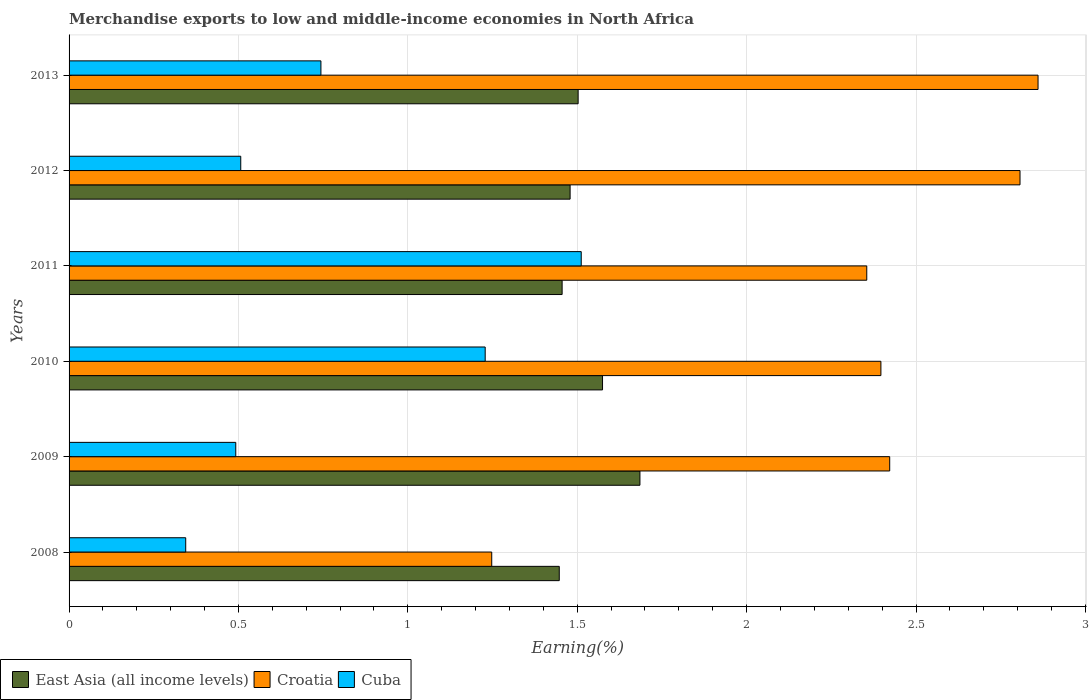How many groups of bars are there?
Provide a short and direct response. 6. How many bars are there on the 3rd tick from the top?
Keep it short and to the point. 3. How many bars are there on the 5th tick from the bottom?
Ensure brevity in your answer.  3. In how many cases, is the number of bars for a given year not equal to the number of legend labels?
Provide a succinct answer. 0. What is the percentage of amount earned from merchandise exports in Cuba in 2009?
Provide a succinct answer. 0.49. Across all years, what is the maximum percentage of amount earned from merchandise exports in Cuba?
Offer a terse response. 1.51. Across all years, what is the minimum percentage of amount earned from merchandise exports in Cuba?
Your answer should be very brief. 0.34. What is the total percentage of amount earned from merchandise exports in Cuba in the graph?
Make the answer very short. 4.83. What is the difference between the percentage of amount earned from merchandise exports in Croatia in 2008 and that in 2009?
Make the answer very short. -1.17. What is the difference between the percentage of amount earned from merchandise exports in Cuba in 2013 and the percentage of amount earned from merchandise exports in East Asia (all income levels) in 2012?
Offer a very short reply. -0.74. What is the average percentage of amount earned from merchandise exports in East Asia (all income levels) per year?
Provide a short and direct response. 1.52. In the year 2013, what is the difference between the percentage of amount earned from merchandise exports in East Asia (all income levels) and percentage of amount earned from merchandise exports in Croatia?
Offer a terse response. -1.36. In how many years, is the percentage of amount earned from merchandise exports in Cuba greater than 1.3 %?
Provide a short and direct response. 1. What is the ratio of the percentage of amount earned from merchandise exports in East Asia (all income levels) in 2010 to that in 2011?
Your answer should be compact. 1.08. What is the difference between the highest and the second highest percentage of amount earned from merchandise exports in Cuba?
Your answer should be very brief. 0.28. What is the difference between the highest and the lowest percentage of amount earned from merchandise exports in East Asia (all income levels)?
Make the answer very short. 0.24. Is the sum of the percentage of amount earned from merchandise exports in Croatia in 2009 and 2012 greater than the maximum percentage of amount earned from merchandise exports in Cuba across all years?
Offer a terse response. Yes. What does the 2nd bar from the top in 2013 represents?
Your answer should be very brief. Croatia. What does the 3rd bar from the bottom in 2011 represents?
Your answer should be very brief. Cuba. Is it the case that in every year, the sum of the percentage of amount earned from merchandise exports in Croatia and percentage of amount earned from merchandise exports in Cuba is greater than the percentage of amount earned from merchandise exports in East Asia (all income levels)?
Your answer should be very brief. Yes. How many bars are there?
Make the answer very short. 18. What is the difference between two consecutive major ticks on the X-axis?
Provide a short and direct response. 0.5. Are the values on the major ticks of X-axis written in scientific E-notation?
Your answer should be compact. No. Does the graph contain grids?
Provide a succinct answer. Yes. Where does the legend appear in the graph?
Make the answer very short. Bottom left. How many legend labels are there?
Make the answer very short. 3. What is the title of the graph?
Provide a short and direct response. Merchandise exports to low and middle-income economies in North Africa. What is the label or title of the X-axis?
Your answer should be compact. Earning(%). What is the Earning(%) of East Asia (all income levels) in 2008?
Provide a short and direct response. 1.45. What is the Earning(%) of Croatia in 2008?
Give a very brief answer. 1.25. What is the Earning(%) of Cuba in 2008?
Make the answer very short. 0.34. What is the Earning(%) of East Asia (all income levels) in 2009?
Your answer should be compact. 1.69. What is the Earning(%) of Croatia in 2009?
Give a very brief answer. 2.42. What is the Earning(%) in Cuba in 2009?
Your response must be concise. 0.49. What is the Earning(%) in East Asia (all income levels) in 2010?
Give a very brief answer. 1.57. What is the Earning(%) in Croatia in 2010?
Ensure brevity in your answer.  2.4. What is the Earning(%) of Cuba in 2010?
Keep it short and to the point. 1.23. What is the Earning(%) of East Asia (all income levels) in 2011?
Give a very brief answer. 1.46. What is the Earning(%) in Croatia in 2011?
Provide a short and direct response. 2.35. What is the Earning(%) in Cuba in 2011?
Give a very brief answer. 1.51. What is the Earning(%) of East Asia (all income levels) in 2012?
Your answer should be compact. 1.48. What is the Earning(%) of Croatia in 2012?
Ensure brevity in your answer.  2.81. What is the Earning(%) in Cuba in 2012?
Your answer should be compact. 0.51. What is the Earning(%) of East Asia (all income levels) in 2013?
Make the answer very short. 1.5. What is the Earning(%) in Croatia in 2013?
Your answer should be very brief. 2.86. What is the Earning(%) of Cuba in 2013?
Provide a short and direct response. 0.74. Across all years, what is the maximum Earning(%) of East Asia (all income levels)?
Make the answer very short. 1.69. Across all years, what is the maximum Earning(%) of Croatia?
Your answer should be very brief. 2.86. Across all years, what is the maximum Earning(%) of Cuba?
Offer a very short reply. 1.51. Across all years, what is the minimum Earning(%) in East Asia (all income levels)?
Ensure brevity in your answer.  1.45. Across all years, what is the minimum Earning(%) of Croatia?
Make the answer very short. 1.25. Across all years, what is the minimum Earning(%) of Cuba?
Offer a very short reply. 0.34. What is the total Earning(%) in East Asia (all income levels) in the graph?
Provide a succinct answer. 9.14. What is the total Earning(%) in Croatia in the graph?
Offer a very short reply. 14.09. What is the total Earning(%) in Cuba in the graph?
Ensure brevity in your answer.  4.83. What is the difference between the Earning(%) in East Asia (all income levels) in 2008 and that in 2009?
Make the answer very short. -0.24. What is the difference between the Earning(%) of Croatia in 2008 and that in 2009?
Make the answer very short. -1.17. What is the difference between the Earning(%) in Cuba in 2008 and that in 2009?
Offer a very short reply. -0.15. What is the difference between the Earning(%) in East Asia (all income levels) in 2008 and that in 2010?
Offer a terse response. -0.13. What is the difference between the Earning(%) of Croatia in 2008 and that in 2010?
Keep it short and to the point. -1.15. What is the difference between the Earning(%) in Cuba in 2008 and that in 2010?
Give a very brief answer. -0.88. What is the difference between the Earning(%) in East Asia (all income levels) in 2008 and that in 2011?
Give a very brief answer. -0.01. What is the difference between the Earning(%) in Croatia in 2008 and that in 2011?
Ensure brevity in your answer.  -1.11. What is the difference between the Earning(%) of Cuba in 2008 and that in 2011?
Give a very brief answer. -1.17. What is the difference between the Earning(%) of East Asia (all income levels) in 2008 and that in 2012?
Your response must be concise. -0.03. What is the difference between the Earning(%) in Croatia in 2008 and that in 2012?
Your answer should be very brief. -1.56. What is the difference between the Earning(%) of Cuba in 2008 and that in 2012?
Your answer should be very brief. -0.16. What is the difference between the Earning(%) in East Asia (all income levels) in 2008 and that in 2013?
Your response must be concise. -0.06. What is the difference between the Earning(%) of Croatia in 2008 and that in 2013?
Provide a short and direct response. -1.61. What is the difference between the Earning(%) of Cuba in 2008 and that in 2013?
Your response must be concise. -0.4. What is the difference between the Earning(%) of East Asia (all income levels) in 2009 and that in 2010?
Offer a very short reply. 0.11. What is the difference between the Earning(%) of Croatia in 2009 and that in 2010?
Your response must be concise. 0.03. What is the difference between the Earning(%) in Cuba in 2009 and that in 2010?
Provide a succinct answer. -0.74. What is the difference between the Earning(%) in East Asia (all income levels) in 2009 and that in 2011?
Make the answer very short. 0.23. What is the difference between the Earning(%) of Croatia in 2009 and that in 2011?
Ensure brevity in your answer.  0.07. What is the difference between the Earning(%) in Cuba in 2009 and that in 2011?
Offer a very short reply. -1.02. What is the difference between the Earning(%) of East Asia (all income levels) in 2009 and that in 2012?
Your answer should be compact. 0.21. What is the difference between the Earning(%) of Croatia in 2009 and that in 2012?
Your answer should be very brief. -0.38. What is the difference between the Earning(%) of Cuba in 2009 and that in 2012?
Offer a terse response. -0.01. What is the difference between the Earning(%) in East Asia (all income levels) in 2009 and that in 2013?
Provide a succinct answer. 0.18. What is the difference between the Earning(%) in Croatia in 2009 and that in 2013?
Offer a very short reply. -0.44. What is the difference between the Earning(%) in Cuba in 2009 and that in 2013?
Make the answer very short. -0.25. What is the difference between the Earning(%) in East Asia (all income levels) in 2010 and that in 2011?
Keep it short and to the point. 0.12. What is the difference between the Earning(%) of Croatia in 2010 and that in 2011?
Ensure brevity in your answer.  0.04. What is the difference between the Earning(%) in Cuba in 2010 and that in 2011?
Your answer should be very brief. -0.28. What is the difference between the Earning(%) of East Asia (all income levels) in 2010 and that in 2012?
Make the answer very short. 0.1. What is the difference between the Earning(%) of Croatia in 2010 and that in 2012?
Provide a succinct answer. -0.41. What is the difference between the Earning(%) in Cuba in 2010 and that in 2012?
Your answer should be compact. 0.72. What is the difference between the Earning(%) of East Asia (all income levels) in 2010 and that in 2013?
Offer a terse response. 0.07. What is the difference between the Earning(%) of Croatia in 2010 and that in 2013?
Your answer should be very brief. -0.46. What is the difference between the Earning(%) in Cuba in 2010 and that in 2013?
Your response must be concise. 0.48. What is the difference between the Earning(%) in East Asia (all income levels) in 2011 and that in 2012?
Ensure brevity in your answer.  -0.02. What is the difference between the Earning(%) of Croatia in 2011 and that in 2012?
Provide a short and direct response. -0.45. What is the difference between the Earning(%) of Cuba in 2011 and that in 2012?
Provide a succinct answer. 1.01. What is the difference between the Earning(%) of East Asia (all income levels) in 2011 and that in 2013?
Offer a very short reply. -0.05. What is the difference between the Earning(%) of Croatia in 2011 and that in 2013?
Your answer should be compact. -0.51. What is the difference between the Earning(%) in Cuba in 2011 and that in 2013?
Provide a short and direct response. 0.77. What is the difference between the Earning(%) of East Asia (all income levels) in 2012 and that in 2013?
Ensure brevity in your answer.  -0.02. What is the difference between the Earning(%) of Croatia in 2012 and that in 2013?
Provide a short and direct response. -0.05. What is the difference between the Earning(%) in Cuba in 2012 and that in 2013?
Provide a short and direct response. -0.24. What is the difference between the Earning(%) in East Asia (all income levels) in 2008 and the Earning(%) in Croatia in 2009?
Keep it short and to the point. -0.98. What is the difference between the Earning(%) of East Asia (all income levels) in 2008 and the Earning(%) of Cuba in 2009?
Your answer should be compact. 0.95. What is the difference between the Earning(%) in Croatia in 2008 and the Earning(%) in Cuba in 2009?
Make the answer very short. 0.76. What is the difference between the Earning(%) of East Asia (all income levels) in 2008 and the Earning(%) of Croatia in 2010?
Your response must be concise. -0.95. What is the difference between the Earning(%) in East Asia (all income levels) in 2008 and the Earning(%) in Cuba in 2010?
Your answer should be very brief. 0.22. What is the difference between the Earning(%) of Croatia in 2008 and the Earning(%) of Cuba in 2010?
Ensure brevity in your answer.  0.02. What is the difference between the Earning(%) of East Asia (all income levels) in 2008 and the Earning(%) of Croatia in 2011?
Your answer should be compact. -0.91. What is the difference between the Earning(%) in East Asia (all income levels) in 2008 and the Earning(%) in Cuba in 2011?
Give a very brief answer. -0.06. What is the difference between the Earning(%) of Croatia in 2008 and the Earning(%) of Cuba in 2011?
Keep it short and to the point. -0.26. What is the difference between the Earning(%) in East Asia (all income levels) in 2008 and the Earning(%) in Croatia in 2012?
Your response must be concise. -1.36. What is the difference between the Earning(%) in East Asia (all income levels) in 2008 and the Earning(%) in Cuba in 2012?
Make the answer very short. 0.94. What is the difference between the Earning(%) of Croatia in 2008 and the Earning(%) of Cuba in 2012?
Ensure brevity in your answer.  0.74. What is the difference between the Earning(%) of East Asia (all income levels) in 2008 and the Earning(%) of Croatia in 2013?
Provide a succinct answer. -1.41. What is the difference between the Earning(%) of East Asia (all income levels) in 2008 and the Earning(%) of Cuba in 2013?
Provide a short and direct response. 0.7. What is the difference between the Earning(%) in Croatia in 2008 and the Earning(%) in Cuba in 2013?
Give a very brief answer. 0.5. What is the difference between the Earning(%) in East Asia (all income levels) in 2009 and the Earning(%) in Croatia in 2010?
Keep it short and to the point. -0.71. What is the difference between the Earning(%) in East Asia (all income levels) in 2009 and the Earning(%) in Cuba in 2010?
Offer a terse response. 0.46. What is the difference between the Earning(%) of Croatia in 2009 and the Earning(%) of Cuba in 2010?
Offer a terse response. 1.19. What is the difference between the Earning(%) in East Asia (all income levels) in 2009 and the Earning(%) in Croatia in 2011?
Your answer should be very brief. -0.67. What is the difference between the Earning(%) in East Asia (all income levels) in 2009 and the Earning(%) in Cuba in 2011?
Offer a terse response. 0.17. What is the difference between the Earning(%) in Croatia in 2009 and the Earning(%) in Cuba in 2011?
Your response must be concise. 0.91. What is the difference between the Earning(%) of East Asia (all income levels) in 2009 and the Earning(%) of Croatia in 2012?
Make the answer very short. -1.12. What is the difference between the Earning(%) of East Asia (all income levels) in 2009 and the Earning(%) of Cuba in 2012?
Give a very brief answer. 1.18. What is the difference between the Earning(%) of Croatia in 2009 and the Earning(%) of Cuba in 2012?
Make the answer very short. 1.92. What is the difference between the Earning(%) of East Asia (all income levels) in 2009 and the Earning(%) of Croatia in 2013?
Give a very brief answer. -1.18. What is the difference between the Earning(%) of East Asia (all income levels) in 2009 and the Earning(%) of Cuba in 2013?
Offer a terse response. 0.94. What is the difference between the Earning(%) in Croatia in 2009 and the Earning(%) in Cuba in 2013?
Give a very brief answer. 1.68. What is the difference between the Earning(%) of East Asia (all income levels) in 2010 and the Earning(%) of Croatia in 2011?
Offer a terse response. -0.78. What is the difference between the Earning(%) of East Asia (all income levels) in 2010 and the Earning(%) of Cuba in 2011?
Give a very brief answer. 0.06. What is the difference between the Earning(%) of Croatia in 2010 and the Earning(%) of Cuba in 2011?
Give a very brief answer. 0.88. What is the difference between the Earning(%) in East Asia (all income levels) in 2010 and the Earning(%) in Croatia in 2012?
Your response must be concise. -1.23. What is the difference between the Earning(%) in East Asia (all income levels) in 2010 and the Earning(%) in Cuba in 2012?
Provide a succinct answer. 1.07. What is the difference between the Earning(%) in Croatia in 2010 and the Earning(%) in Cuba in 2012?
Give a very brief answer. 1.89. What is the difference between the Earning(%) in East Asia (all income levels) in 2010 and the Earning(%) in Croatia in 2013?
Make the answer very short. -1.29. What is the difference between the Earning(%) in East Asia (all income levels) in 2010 and the Earning(%) in Cuba in 2013?
Make the answer very short. 0.83. What is the difference between the Earning(%) in Croatia in 2010 and the Earning(%) in Cuba in 2013?
Ensure brevity in your answer.  1.65. What is the difference between the Earning(%) of East Asia (all income levels) in 2011 and the Earning(%) of Croatia in 2012?
Keep it short and to the point. -1.35. What is the difference between the Earning(%) in East Asia (all income levels) in 2011 and the Earning(%) in Cuba in 2012?
Offer a very short reply. 0.95. What is the difference between the Earning(%) of Croatia in 2011 and the Earning(%) of Cuba in 2012?
Your response must be concise. 1.85. What is the difference between the Earning(%) of East Asia (all income levels) in 2011 and the Earning(%) of Croatia in 2013?
Keep it short and to the point. -1.4. What is the difference between the Earning(%) of East Asia (all income levels) in 2011 and the Earning(%) of Cuba in 2013?
Ensure brevity in your answer.  0.71. What is the difference between the Earning(%) of Croatia in 2011 and the Earning(%) of Cuba in 2013?
Make the answer very short. 1.61. What is the difference between the Earning(%) of East Asia (all income levels) in 2012 and the Earning(%) of Croatia in 2013?
Your answer should be compact. -1.38. What is the difference between the Earning(%) in East Asia (all income levels) in 2012 and the Earning(%) in Cuba in 2013?
Your response must be concise. 0.74. What is the difference between the Earning(%) in Croatia in 2012 and the Earning(%) in Cuba in 2013?
Keep it short and to the point. 2.06. What is the average Earning(%) in East Asia (all income levels) per year?
Offer a very short reply. 1.52. What is the average Earning(%) of Croatia per year?
Ensure brevity in your answer.  2.35. What is the average Earning(%) in Cuba per year?
Ensure brevity in your answer.  0.8. In the year 2008, what is the difference between the Earning(%) in East Asia (all income levels) and Earning(%) in Croatia?
Make the answer very short. 0.2. In the year 2008, what is the difference between the Earning(%) in East Asia (all income levels) and Earning(%) in Cuba?
Your answer should be compact. 1.1. In the year 2008, what is the difference between the Earning(%) of Croatia and Earning(%) of Cuba?
Your response must be concise. 0.9. In the year 2009, what is the difference between the Earning(%) in East Asia (all income levels) and Earning(%) in Croatia?
Your response must be concise. -0.74. In the year 2009, what is the difference between the Earning(%) in East Asia (all income levels) and Earning(%) in Cuba?
Ensure brevity in your answer.  1.19. In the year 2009, what is the difference between the Earning(%) of Croatia and Earning(%) of Cuba?
Keep it short and to the point. 1.93. In the year 2010, what is the difference between the Earning(%) of East Asia (all income levels) and Earning(%) of Croatia?
Provide a short and direct response. -0.82. In the year 2010, what is the difference between the Earning(%) of East Asia (all income levels) and Earning(%) of Cuba?
Provide a succinct answer. 0.35. In the year 2010, what is the difference between the Earning(%) in Croatia and Earning(%) in Cuba?
Keep it short and to the point. 1.17. In the year 2011, what is the difference between the Earning(%) of East Asia (all income levels) and Earning(%) of Croatia?
Provide a succinct answer. -0.9. In the year 2011, what is the difference between the Earning(%) in East Asia (all income levels) and Earning(%) in Cuba?
Keep it short and to the point. -0.06. In the year 2011, what is the difference between the Earning(%) of Croatia and Earning(%) of Cuba?
Give a very brief answer. 0.84. In the year 2012, what is the difference between the Earning(%) in East Asia (all income levels) and Earning(%) in Croatia?
Give a very brief answer. -1.33. In the year 2012, what is the difference between the Earning(%) of East Asia (all income levels) and Earning(%) of Cuba?
Offer a very short reply. 0.97. In the year 2012, what is the difference between the Earning(%) in Croatia and Earning(%) in Cuba?
Provide a succinct answer. 2.3. In the year 2013, what is the difference between the Earning(%) of East Asia (all income levels) and Earning(%) of Croatia?
Give a very brief answer. -1.36. In the year 2013, what is the difference between the Earning(%) in East Asia (all income levels) and Earning(%) in Cuba?
Your answer should be very brief. 0.76. In the year 2013, what is the difference between the Earning(%) in Croatia and Earning(%) in Cuba?
Offer a terse response. 2.12. What is the ratio of the Earning(%) in East Asia (all income levels) in 2008 to that in 2009?
Keep it short and to the point. 0.86. What is the ratio of the Earning(%) in Croatia in 2008 to that in 2009?
Give a very brief answer. 0.52. What is the ratio of the Earning(%) of Cuba in 2008 to that in 2009?
Ensure brevity in your answer.  0.7. What is the ratio of the Earning(%) of East Asia (all income levels) in 2008 to that in 2010?
Provide a short and direct response. 0.92. What is the ratio of the Earning(%) in Croatia in 2008 to that in 2010?
Your answer should be very brief. 0.52. What is the ratio of the Earning(%) of Cuba in 2008 to that in 2010?
Provide a short and direct response. 0.28. What is the ratio of the Earning(%) in East Asia (all income levels) in 2008 to that in 2011?
Keep it short and to the point. 0.99. What is the ratio of the Earning(%) of Croatia in 2008 to that in 2011?
Keep it short and to the point. 0.53. What is the ratio of the Earning(%) in Cuba in 2008 to that in 2011?
Offer a terse response. 0.23. What is the ratio of the Earning(%) in East Asia (all income levels) in 2008 to that in 2012?
Keep it short and to the point. 0.98. What is the ratio of the Earning(%) in Croatia in 2008 to that in 2012?
Keep it short and to the point. 0.44. What is the ratio of the Earning(%) in Cuba in 2008 to that in 2012?
Provide a succinct answer. 0.68. What is the ratio of the Earning(%) of East Asia (all income levels) in 2008 to that in 2013?
Provide a succinct answer. 0.96. What is the ratio of the Earning(%) of Croatia in 2008 to that in 2013?
Your response must be concise. 0.44. What is the ratio of the Earning(%) of Cuba in 2008 to that in 2013?
Give a very brief answer. 0.46. What is the ratio of the Earning(%) of East Asia (all income levels) in 2009 to that in 2010?
Make the answer very short. 1.07. What is the ratio of the Earning(%) of Croatia in 2009 to that in 2010?
Make the answer very short. 1.01. What is the ratio of the Earning(%) in Cuba in 2009 to that in 2010?
Offer a terse response. 0.4. What is the ratio of the Earning(%) of East Asia (all income levels) in 2009 to that in 2011?
Give a very brief answer. 1.16. What is the ratio of the Earning(%) in Croatia in 2009 to that in 2011?
Your answer should be compact. 1.03. What is the ratio of the Earning(%) in Cuba in 2009 to that in 2011?
Make the answer very short. 0.33. What is the ratio of the Earning(%) of East Asia (all income levels) in 2009 to that in 2012?
Give a very brief answer. 1.14. What is the ratio of the Earning(%) of Croatia in 2009 to that in 2012?
Your answer should be very brief. 0.86. What is the ratio of the Earning(%) in Cuba in 2009 to that in 2012?
Give a very brief answer. 0.97. What is the ratio of the Earning(%) in East Asia (all income levels) in 2009 to that in 2013?
Ensure brevity in your answer.  1.12. What is the ratio of the Earning(%) of Croatia in 2009 to that in 2013?
Your answer should be very brief. 0.85. What is the ratio of the Earning(%) in Cuba in 2009 to that in 2013?
Provide a succinct answer. 0.66. What is the ratio of the Earning(%) in East Asia (all income levels) in 2010 to that in 2011?
Make the answer very short. 1.08. What is the ratio of the Earning(%) in Croatia in 2010 to that in 2011?
Offer a very short reply. 1.02. What is the ratio of the Earning(%) in Cuba in 2010 to that in 2011?
Make the answer very short. 0.81. What is the ratio of the Earning(%) in East Asia (all income levels) in 2010 to that in 2012?
Offer a terse response. 1.06. What is the ratio of the Earning(%) of Croatia in 2010 to that in 2012?
Your answer should be very brief. 0.85. What is the ratio of the Earning(%) in Cuba in 2010 to that in 2012?
Provide a short and direct response. 2.42. What is the ratio of the Earning(%) of East Asia (all income levels) in 2010 to that in 2013?
Your answer should be compact. 1.05. What is the ratio of the Earning(%) in Croatia in 2010 to that in 2013?
Offer a terse response. 0.84. What is the ratio of the Earning(%) in Cuba in 2010 to that in 2013?
Keep it short and to the point. 1.65. What is the ratio of the Earning(%) in East Asia (all income levels) in 2011 to that in 2012?
Offer a terse response. 0.98. What is the ratio of the Earning(%) in Croatia in 2011 to that in 2012?
Provide a succinct answer. 0.84. What is the ratio of the Earning(%) of Cuba in 2011 to that in 2012?
Ensure brevity in your answer.  2.98. What is the ratio of the Earning(%) in East Asia (all income levels) in 2011 to that in 2013?
Your response must be concise. 0.97. What is the ratio of the Earning(%) of Croatia in 2011 to that in 2013?
Provide a succinct answer. 0.82. What is the ratio of the Earning(%) in Cuba in 2011 to that in 2013?
Ensure brevity in your answer.  2.03. What is the ratio of the Earning(%) in East Asia (all income levels) in 2012 to that in 2013?
Your answer should be compact. 0.98. What is the ratio of the Earning(%) of Croatia in 2012 to that in 2013?
Offer a very short reply. 0.98. What is the ratio of the Earning(%) in Cuba in 2012 to that in 2013?
Offer a very short reply. 0.68. What is the difference between the highest and the second highest Earning(%) in East Asia (all income levels)?
Keep it short and to the point. 0.11. What is the difference between the highest and the second highest Earning(%) of Croatia?
Give a very brief answer. 0.05. What is the difference between the highest and the second highest Earning(%) of Cuba?
Offer a terse response. 0.28. What is the difference between the highest and the lowest Earning(%) in East Asia (all income levels)?
Your answer should be compact. 0.24. What is the difference between the highest and the lowest Earning(%) of Croatia?
Your answer should be compact. 1.61. What is the difference between the highest and the lowest Earning(%) in Cuba?
Make the answer very short. 1.17. 